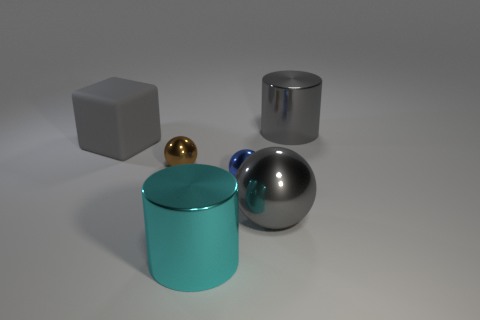There is a cyan thing that is the same size as the gray ball; what is its material? The cyan object, sharing a similar size with the gray ball, appears to have a glossy finish indicative of a material like painted metal or polished ceramic, which are both known for such reflective properties. 